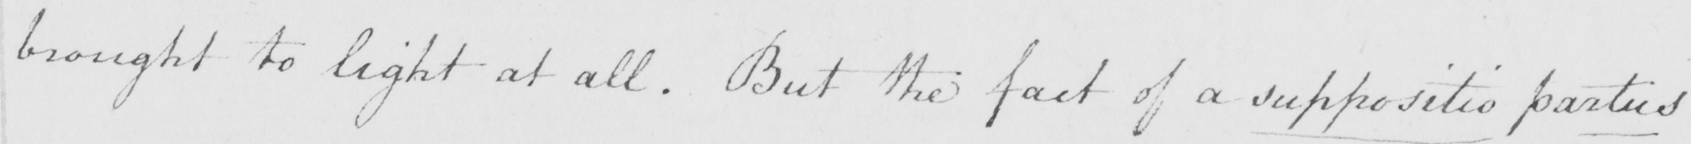Can you read and transcribe this handwriting? brought to light at all . But the fact of a suppositio partus 